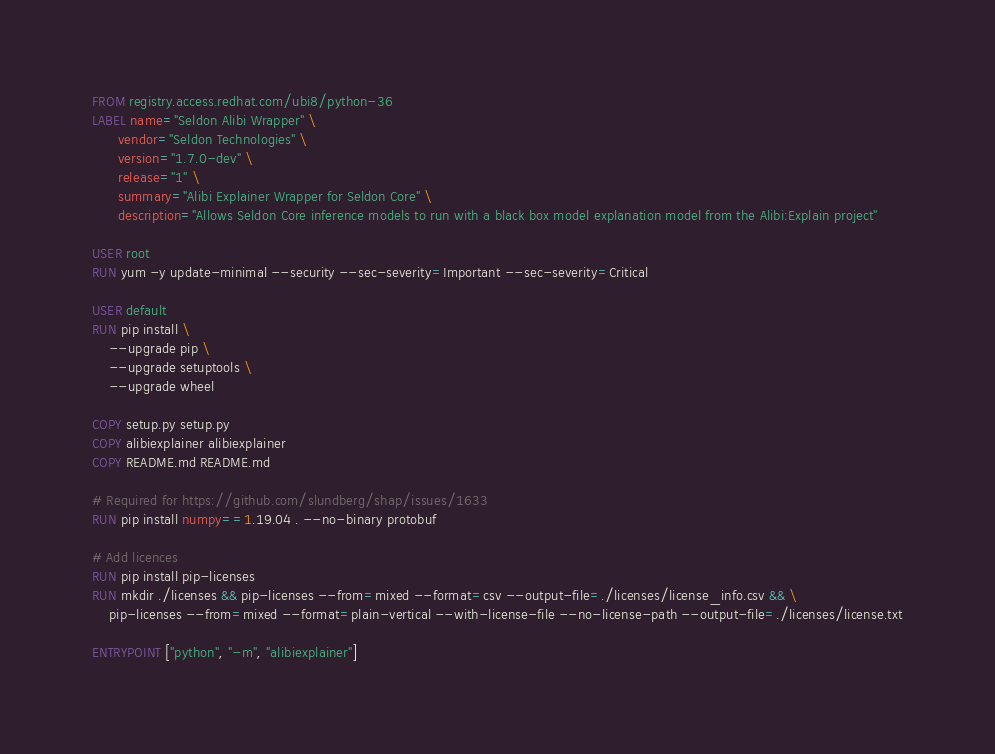<code> <loc_0><loc_0><loc_500><loc_500><_Dockerfile_>FROM registry.access.redhat.com/ubi8/python-36
LABEL name="Seldon Alibi Wrapper" \
      vendor="Seldon Technologies" \
      version="1.7.0-dev" \
      release="1" \
      summary="Alibi Explainer Wrapper for Seldon Core" \
      description="Allows Seldon Core inference models to run with a black box model explanation model from the Alibi:Explain project"

USER root
RUN yum -y update-minimal --security --sec-severity=Important --sec-severity=Critical

USER default
RUN pip install \
    --upgrade pip \
    --upgrade setuptools \
    --upgrade wheel

COPY setup.py setup.py
COPY alibiexplainer alibiexplainer
COPY README.md README.md

# Required for https://github.com/slundberg/shap/issues/1633
RUN pip install numpy==1.19.04 . --no-binary protobuf

# Add licences
RUN pip install pip-licenses
RUN mkdir ./licenses && pip-licenses --from=mixed --format=csv --output-file=./licenses/license_info.csv && \
    pip-licenses --from=mixed --format=plain-vertical --with-license-file --no-license-path --output-file=./licenses/license.txt

ENTRYPOINT ["python", "-m", "alibiexplainer"]
</code> 